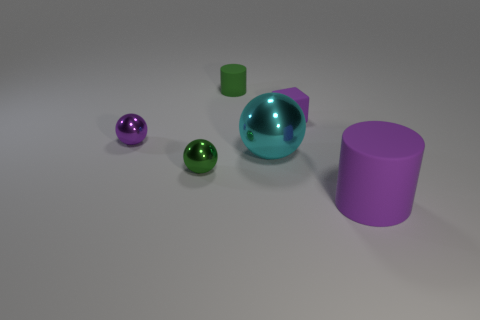Add 2 green balls. How many objects exist? 8 Subtract all cylinders. How many objects are left? 4 Add 5 red metal balls. How many red metal balls exist? 5 Subtract 1 green spheres. How many objects are left? 5 Subtract all big purple metal spheres. Subtract all rubber objects. How many objects are left? 3 Add 6 small shiny things. How many small shiny things are left? 8 